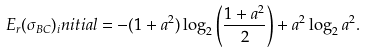Convert formula to latex. <formula><loc_0><loc_0><loc_500><loc_500>E _ { r } ( \sigma _ { B C } ) _ { i } n i t i a l = - ( 1 + a ^ { 2 } ) \log _ { 2 } \left ( \frac { 1 + a ^ { 2 } } { 2 } \right ) + a ^ { 2 } \log _ { 2 } a ^ { 2 } .</formula> 